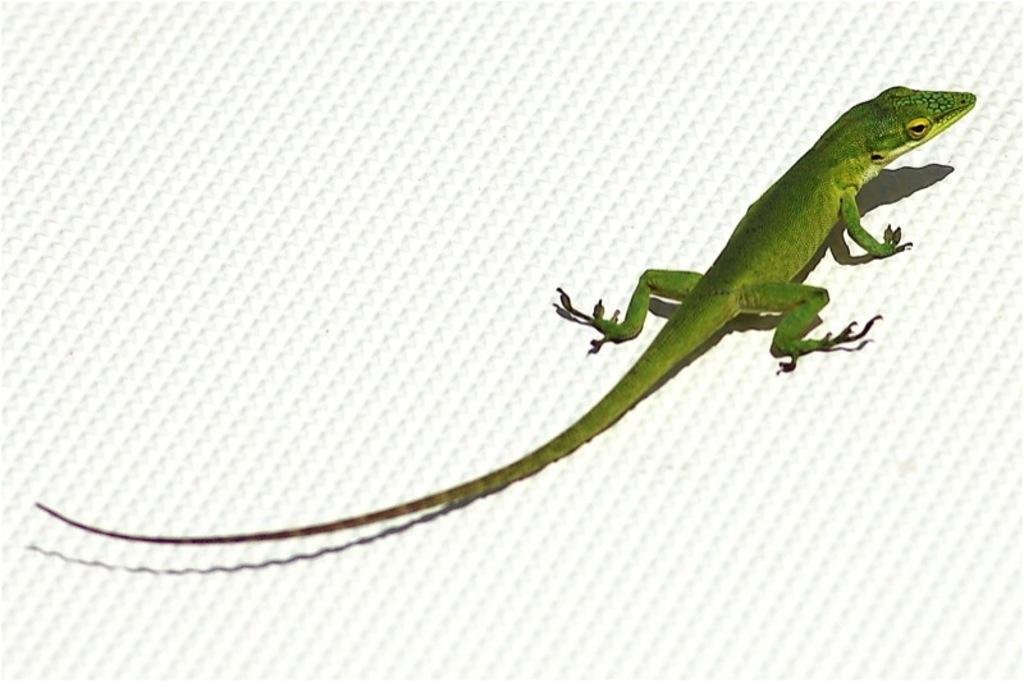In one or two sentences, can you explain what this image depicts? This is an edited picture. I can see a reptile on an object. 